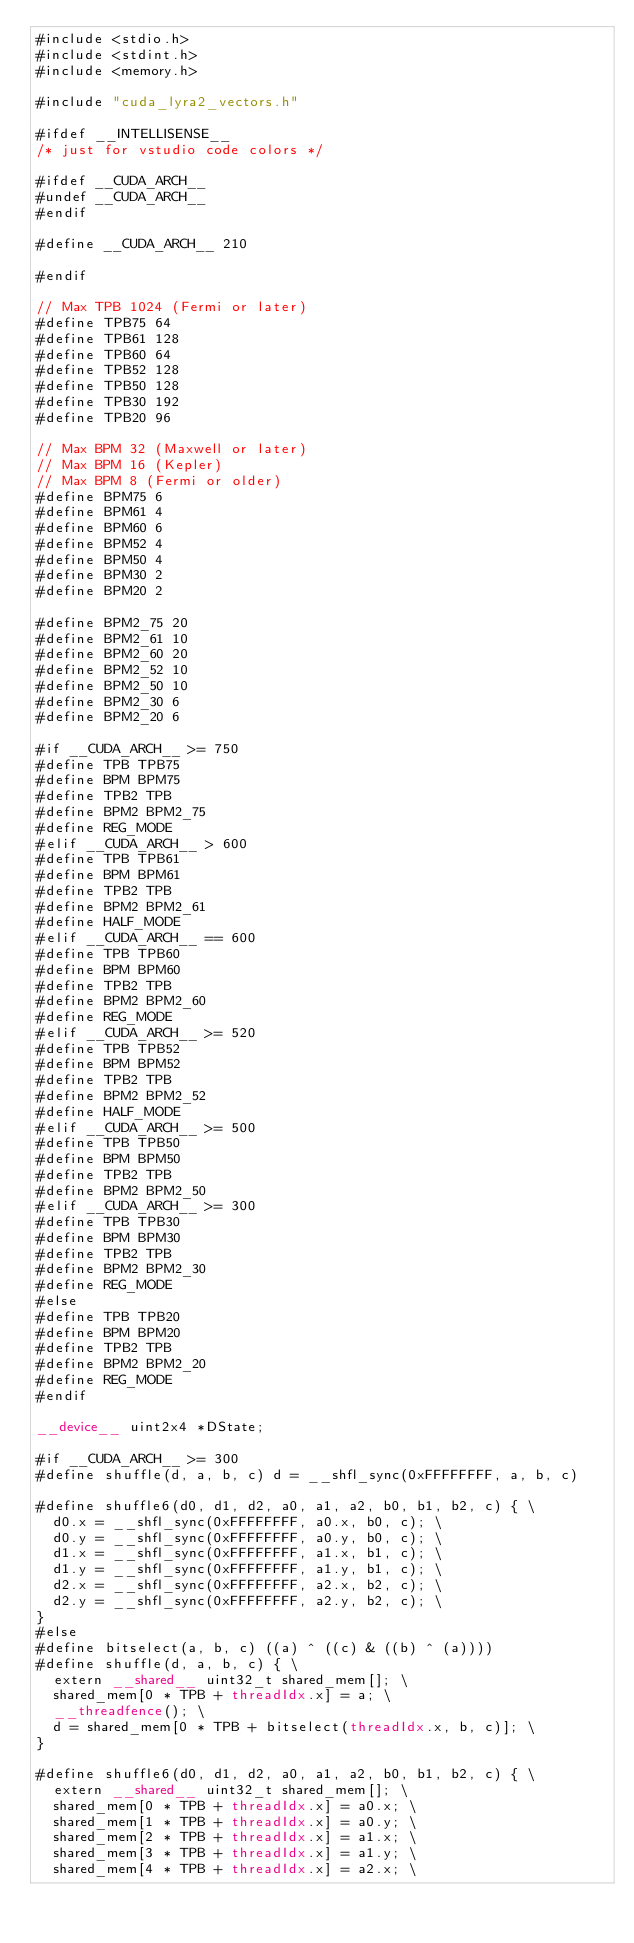Convert code to text. <code><loc_0><loc_0><loc_500><loc_500><_Cuda_>#include <stdio.h>
#include <stdint.h>
#include <memory.h>

#include "cuda_lyra2_vectors.h"

#ifdef __INTELLISENSE__
/* just for vstudio code colors */

#ifdef __CUDA_ARCH__
#undef __CUDA_ARCH__
#endif

#define __CUDA_ARCH__ 210

#endif

// Max TPB 1024 (Fermi or later)
#define TPB75 64
#define TPB61 128
#define TPB60 64
#define TPB52 128
#define TPB50 128
#define TPB30 192
#define TPB20 96

// Max BPM 32 (Maxwell or later)
// Max BPM 16 (Kepler)
// Max BPM 8 (Fermi or older)
#define BPM75 6
#define BPM61 4
#define BPM60 6
#define BPM52 4
#define BPM50 4
#define BPM30 2
#define BPM20 2

#define BPM2_75 20
#define BPM2_61 10
#define BPM2_60 20
#define BPM2_52 10
#define BPM2_50 10
#define BPM2_30 6
#define BPM2_20 6

#if __CUDA_ARCH__ >= 750
#define TPB TPB75
#define BPM BPM75
#define TPB2 TPB
#define BPM2 BPM2_75
#define REG_MODE
#elif __CUDA_ARCH__ > 600
#define TPB TPB61
#define BPM BPM61
#define TPB2 TPB
#define BPM2 BPM2_61
#define HALF_MODE
#elif __CUDA_ARCH__ == 600
#define TPB TPB60
#define BPM BPM60
#define TPB2 TPB
#define BPM2 BPM2_60
#define REG_MODE
#elif __CUDA_ARCH__ >= 520
#define TPB TPB52
#define BPM BPM52
#define TPB2 TPB
#define BPM2 BPM2_52
#define HALF_MODE
#elif __CUDA_ARCH__ >= 500
#define TPB TPB50
#define BPM BPM50
#define TPB2 TPB
#define BPM2 BPM2_50
#elif __CUDA_ARCH__ >= 300
#define TPB TPB30
#define BPM BPM30
#define TPB2 TPB
#define BPM2 BPM2_30
#define REG_MODE
#else
#define TPB TPB20
#define BPM BPM20
#define TPB2 TPB
#define BPM2 BPM2_20
#define REG_MODE
#endif

__device__ uint2x4 *DState;

#if __CUDA_ARCH__ >= 300
#define shuffle(d, a, b, c) d = __shfl_sync(0xFFFFFFFF, a, b, c)

#define shuffle6(d0, d1, d2, a0, a1, a2, b0, b1, b2, c) { \
	d0.x = __shfl_sync(0xFFFFFFFF, a0.x, b0, c); \
	d0.y = __shfl_sync(0xFFFFFFFF, a0.y, b0, c); \
	d1.x = __shfl_sync(0xFFFFFFFF, a1.x, b1, c); \
	d1.y = __shfl_sync(0xFFFFFFFF, a1.y, b1, c); \
	d2.x = __shfl_sync(0xFFFFFFFF, a2.x, b2, c); \
	d2.y = __shfl_sync(0xFFFFFFFF, a2.y, b2, c); \
}
#else
#define bitselect(a, b, c) ((a) ^ ((c) & ((b) ^ (a))))
#define shuffle(d, a, b, c) { \
	extern __shared__ uint32_t shared_mem[]; \
	shared_mem[0 * TPB + threadIdx.x] = a; \
	__threadfence(); \
	d = shared_mem[0 * TPB + bitselect(threadIdx.x, b, c)]; \
}

#define shuffle6(d0, d1, d2, a0, a1, a2, b0, b1, b2, c) { \
	extern __shared__ uint32_t shared_mem[]; \
	shared_mem[0 * TPB + threadIdx.x] = a0.x; \
	shared_mem[1 * TPB + threadIdx.x] = a0.y; \
	shared_mem[2 * TPB + threadIdx.x] = a1.x; \
	shared_mem[3 * TPB + threadIdx.x] = a1.y; \
	shared_mem[4 * TPB + threadIdx.x] = a2.x; \</code> 